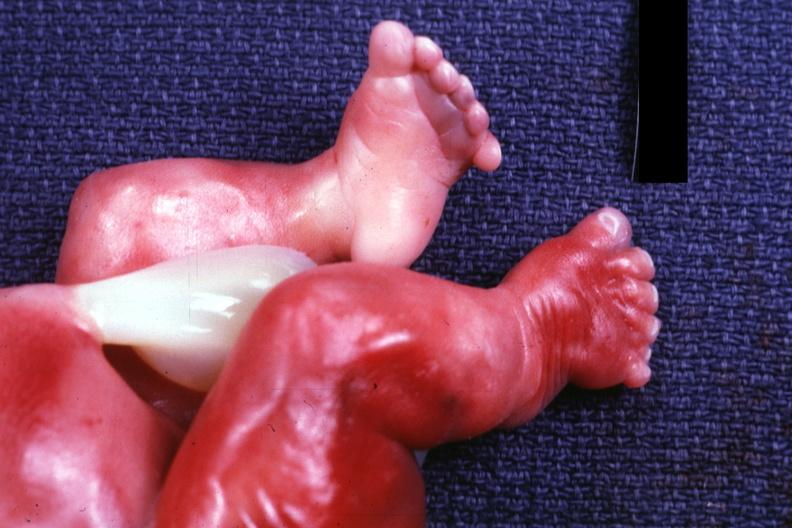s six digits present?
Answer the question using a single word or phrase. Six 